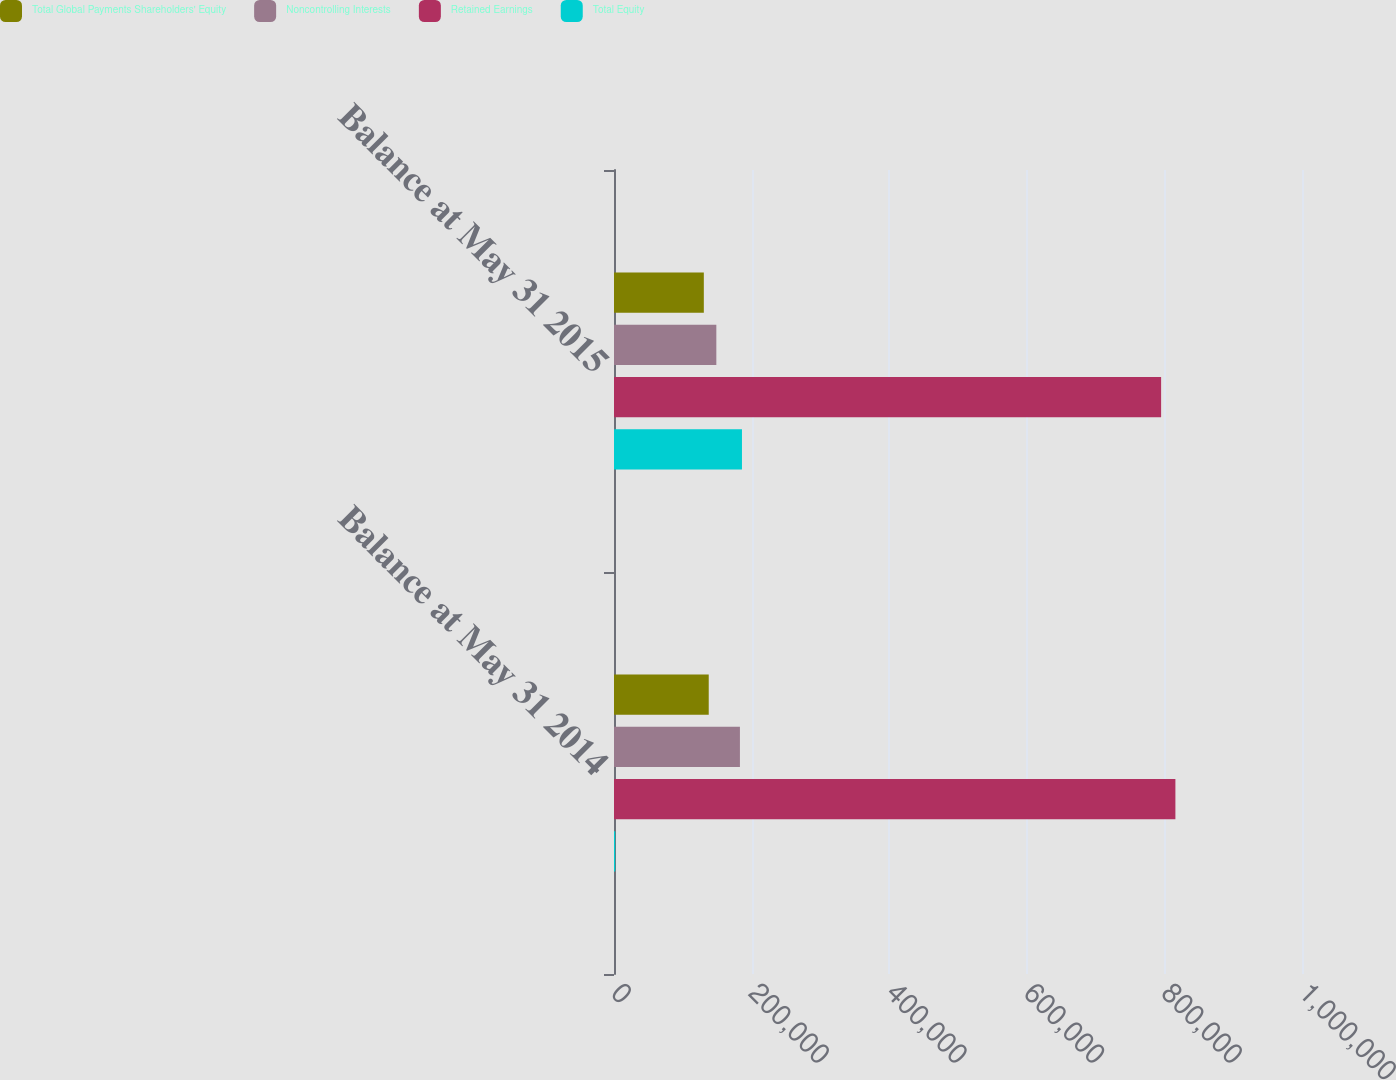Convert chart to OTSL. <chart><loc_0><loc_0><loc_500><loc_500><stacked_bar_chart><ecel><fcel>Balance at May 31 2014<fcel>Balance at May 31 2015<nl><fcel>Total Global Payments Shareholders' Equity<fcel>137692<fcel>130558<nl><fcel>Noncontrolling Interests<fcel>183023<fcel>148742<nl><fcel>Retained Earnings<fcel>815980<fcel>795226<nl><fcel>Total Equity<fcel>1776<fcel>185992<nl></chart> 